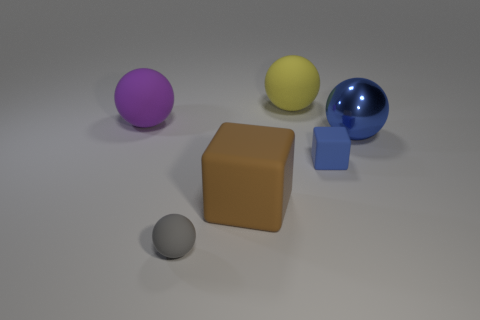Is there anything else that is made of the same material as the big blue object?
Ensure brevity in your answer.  No. Is there a tiny blue object made of the same material as the small cube?
Offer a terse response. No. What is the color of the metal object?
Your response must be concise. Blue. There is a matte thing behind the purple matte sphere; is its shape the same as the large shiny object?
Provide a succinct answer. Yes. There is a tiny rubber thing to the left of the sphere behind the big object that is on the left side of the small gray sphere; what shape is it?
Offer a very short reply. Sphere. What material is the small object that is left of the small block?
Keep it short and to the point. Rubber. There is a shiny object that is the same size as the purple matte sphere; what color is it?
Provide a short and direct response. Blue. What number of other objects are there of the same shape as the large blue thing?
Give a very brief answer. 3. Is the gray thing the same size as the purple thing?
Ensure brevity in your answer.  No. Are there more tiny matte spheres that are on the right side of the big blue metallic object than purple matte objects that are right of the purple object?
Your answer should be compact. No. 